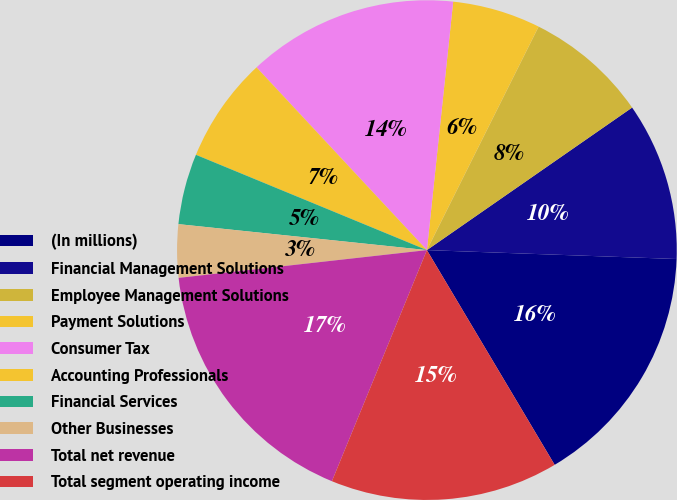Convert chart. <chart><loc_0><loc_0><loc_500><loc_500><pie_chart><fcel>(In millions)<fcel>Financial Management Solutions<fcel>Employee Management Solutions<fcel>Payment Solutions<fcel>Consumer Tax<fcel>Accounting Professionals<fcel>Financial Services<fcel>Other Businesses<fcel>Total net revenue<fcel>Total segment operating income<nl><fcel>15.89%<fcel>10.23%<fcel>7.96%<fcel>5.7%<fcel>13.62%<fcel>6.83%<fcel>4.57%<fcel>3.43%<fcel>17.02%<fcel>14.75%<nl></chart> 